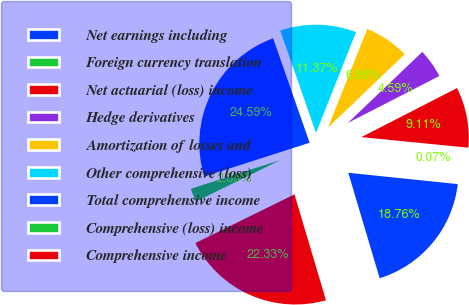Convert chart to OTSL. <chart><loc_0><loc_0><loc_500><loc_500><pie_chart><fcel>Net earnings including<fcel>Foreign currency translation<fcel>Net actuarial (loss) income<fcel>Hedge derivatives<fcel>Amortization of losses and<fcel>Other comprehensive (loss)<fcel>Total comprehensive income<fcel>Comprehensive (loss) income<fcel>Comprehensive income<nl><fcel>18.76%<fcel>0.07%<fcel>9.11%<fcel>4.59%<fcel>6.85%<fcel>11.37%<fcel>24.59%<fcel>2.33%<fcel>22.33%<nl></chart> 